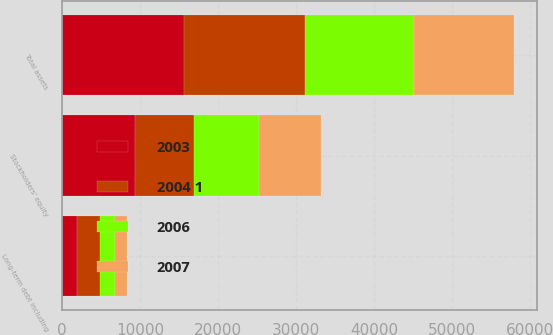<chart> <loc_0><loc_0><loc_500><loc_500><stacked_bar_chart><ecel><fcel>Total assets<fcel>Long-term debt including<fcel>Stockholders' equity<nl><fcel>2004 1<fcel>15598<fcel>2938<fcel>7548<nl><fcel>2003<fcel>15601<fcel>1911<fcel>9337<nl><fcel>2006<fcel>13992<fcel>1918<fcel>8376<nl><fcel>2007<fcel>12776<fcel>1590<fcel>7938<nl></chart> 